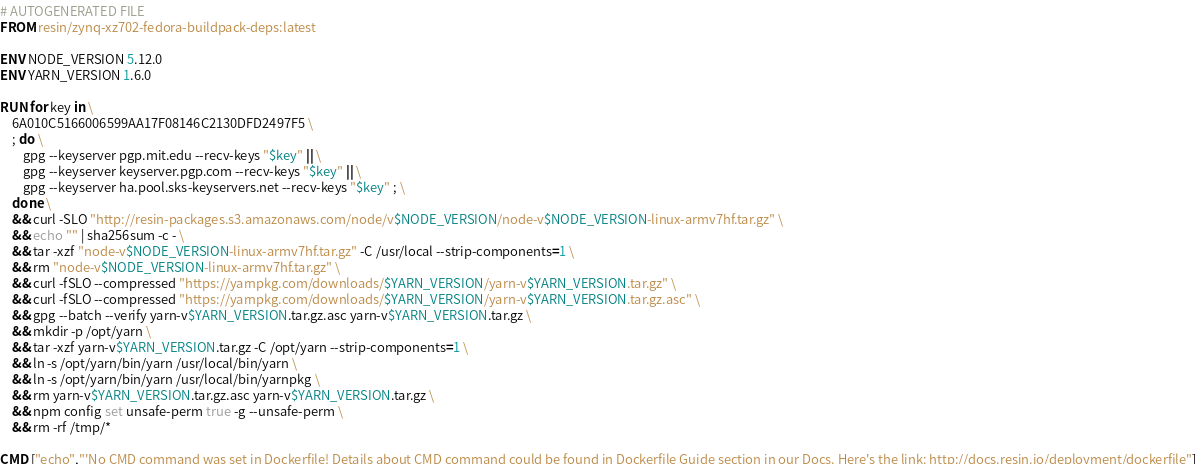Convert code to text. <code><loc_0><loc_0><loc_500><loc_500><_Dockerfile_># AUTOGENERATED FILE
FROM resin/zynq-xz702-fedora-buildpack-deps:latest

ENV NODE_VERSION 5.12.0
ENV YARN_VERSION 1.6.0

RUN for key in \
	6A010C5166006599AA17F08146C2130DFD2497F5 \
	; do \
		gpg --keyserver pgp.mit.edu --recv-keys "$key" || \
		gpg --keyserver keyserver.pgp.com --recv-keys "$key" || \
		gpg --keyserver ha.pool.sks-keyservers.net --recv-keys "$key" ; \
	done \
	&& curl -SLO "http://resin-packages.s3.amazonaws.com/node/v$NODE_VERSION/node-v$NODE_VERSION-linux-armv7hf.tar.gz" \
	&& echo "" | sha256sum -c - \
	&& tar -xzf "node-v$NODE_VERSION-linux-armv7hf.tar.gz" -C /usr/local --strip-components=1 \
	&& rm "node-v$NODE_VERSION-linux-armv7hf.tar.gz" \
	&& curl -fSLO --compressed "https://yarnpkg.com/downloads/$YARN_VERSION/yarn-v$YARN_VERSION.tar.gz" \
	&& curl -fSLO --compressed "https://yarnpkg.com/downloads/$YARN_VERSION/yarn-v$YARN_VERSION.tar.gz.asc" \
	&& gpg --batch --verify yarn-v$YARN_VERSION.tar.gz.asc yarn-v$YARN_VERSION.tar.gz \
	&& mkdir -p /opt/yarn \
	&& tar -xzf yarn-v$YARN_VERSION.tar.gz -C /opt/yarn --strip-components=1 \
	&& ln -s /opt/yarn/bin/yarn /usr/local/bin/yarn \
	&& ln -s /opt/yarn/bin/yarn /usr/local/bin/yarnpkg \
	&& rm yarn-v$YARN_VERSION.tar.gz.asc yarn-v$YARN_VERSION.tar.gz \
	&& npm config set unsafe-perm true -g --unsafe-perm \
	&& rm -rf /tmp/*

CMD ["echo","'No CMD command was set in Dockerfile! Details about CMD command could be found in Dockerfile Guide section in our Docs. Here's the link: http://docs.resin.io/deployment/dockerfile"]
</code> 